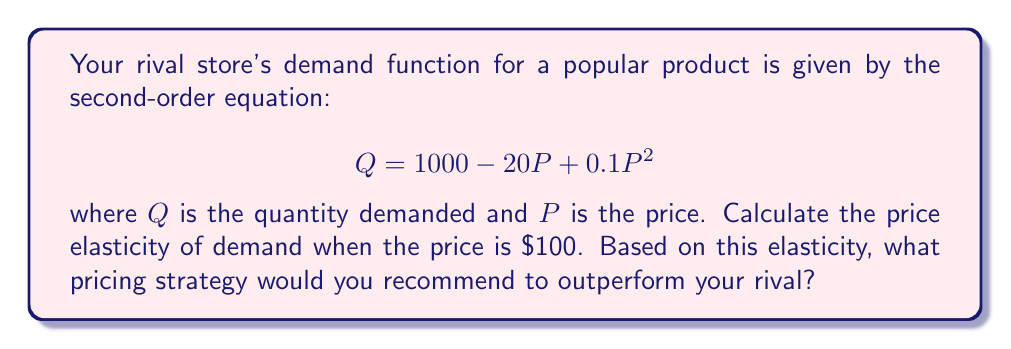Show me your answer to this math problem. To calculate the price elasticity of demand using a second-order equation, we need to follow these steps:

1) The general formula for price elasticity of demand is:

   $$E_d = -\frac{dQ}{dP} \cdot \frac{P}{Q}$$

2) First, we need to find $\frac{dQ}{dP}$ by differentiating the demand function:

   $$\frac{dQ}{dP} = -20 + 0.2P$$

3) Next, we need to calculate $Q$ when $P = 100$:

   $$Q = 1000 - 20(100) + 0.1(100)^2 = 1000 - 2000 + 1000 = 0$$

4) Now we can substitute these values into the elasticity formula:

   $$E_d = -(-20 + 0.2(100)) \cdot \frac{100}{0}$$

   $$E_d = -(0) \cdot \frac{100}{0}$$

5) This results in an undefined elasticity, which occurs at the turning point of the demand curve where $Q = 0$.

6) To interpret this, we need to consider the behavior of the function near this point. Just below $P = 100$, demand becomes positive and elasticity approaches negative infinity. Just above $P = 100$, demand becomes negative (economically meaningless) and elasticity approaches positive infinity.

7) In practical terms, this means that at $P = 100$, demand is perfectly elastic. Any price increase above $100 will reduce demand to zero, while any price decrease below $100 will create positive demand.
Answer: The price elasticity of demand at $P = 100$ is undefined mathematically, but economically interpreted as perfectly elastic. To outperform the rival, you should price your similar product slightly below $100 to capture the entire market demand, as your competitor's demand drops to zero above this price point. 